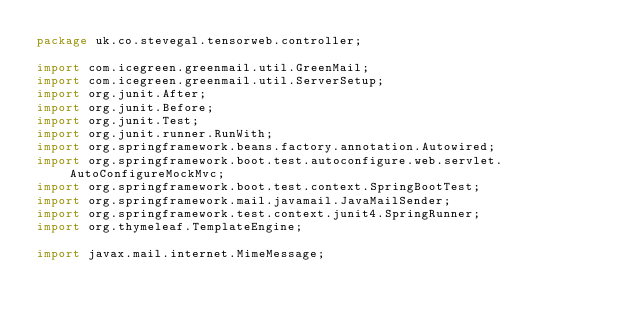<code> <loc_0><loc_0><loc_500><loc_500><_Java_>package uk.co.stevegal.tensorweb.controller;

import com.icegreen.greenmail.util.GreenMail;
import com.icegreen.greenmail.util.ServerSetup;
import org.junit.After;
import org.junit.Before;
import org.junit.Test;
import org.junit.runner.RunWith;
import org.springframework.beans.factory.annotation.Autowired;
import org.springframework.boot.test.autoconfigure.web.servlet.AutoConfigureMockMvc;
import org.springframework.boot.test.context.SpringBootTest;
import org.springframework.mail.javamail.JavaMailSender;
import org.springframework.test.context.junit4.SpringRunner;
import org.thymeleaf.TemplateEngine;

import javax.mail.internet.MimeMessage;
</code> 